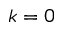<formula> <loc_0><loc_0><loc_500><loc_500>\boldsymbol k = 0</formula> 